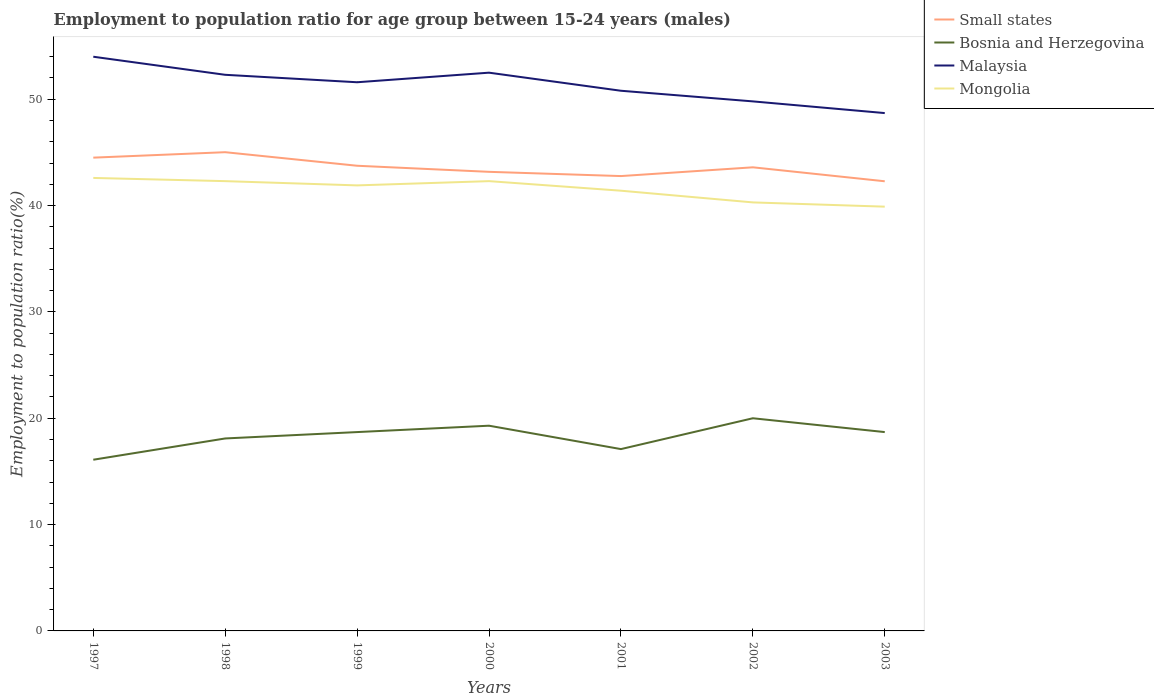Is the number of lines equal to the number of legend labels?
Provide a short and direct response. Yes. Across all years, what is the maximum employment to population ratio in Small states?
Your answer should be compact. 42.29. In which year was the employment to population ratio in Small states maximum?
Your answer should be very brief. 2003. What is the total employment to population ratio in Small states in the graph?
Keep it short and to the point. 0.89. What is the difference between the highest and the second highest employment to population ratio in Small states?
Your response must be concise. 2.73. How many lines are there?
Provide a succinct answer. 4. How many years are there in the graph?
Your response must be concise. 7. What is the difference between two consecutive major ticks on the Y-axis?
Ensure brevity in your answer.  10. Are the values on the major ticks of Y-axis written in scientific E-notation?
Provide a succinct answer. No. How many legend labels are there?
Keep it short and to the point. 4. What is the title of the graph?
Give a very brief answer. Employment to population ratio for age group between 15-24 years (males). What is the label or title of the X-axis?
Your answer should be compact. Years. What is the label or title of the Y-axis?
Keep it short and to the point. Employment to population ratio(%). What is the Employment to population ratio(%) of Small states in 1997?
Offer a very short reply. 44.51. What is the Employment to population ratio(%) of Bosnia and Herzegovina in 1997?
Offer a terse response. 16.1. What is the Employment to population ratio(%) of Mongolia in 1997?
Provide a short and direct response. 42.6. What is the Employment to population ratio(%) of Small states in 1998?
Your response must be concise. 45.02. What is the Employment to population ratio(%) in Bosnia and Herzegovina in 1998?
Ensure brevity in your answer.  18.1. What is the Employment to population ratio(%) in Malaysia in 1998?
Keep it short and to the point. 52.3. What is the Employment to population ratio(%) of Mongolia in 1998?
Your answer should be very brief. 42.3. What is the Employment to population ratio(%) in Small states in 1999?
Make the answer very short. 43.75. What is the Employment to population ratio(%) in Bosnia and Herzegovina in 1999?
Ensure brevity in your answer.  18.7. What is the Employment to population ratio(%) in Malaysia in 1999?
Your answer should be compact. 51.6. What is the Employment to population ratio(%) of Mongolia in 1999?
Your answer should be compact. 41.9. What is the Employment to population ratio(%) in Small states in 2000?
Your answer should be very brief. 43.17. What is the Employment to population ratio(%) in Bosnia and Herzegovina in 2000?
Offer a terse response. 19.3. What is the Employment to population ratio(%) in Malaysia in 2000?
Keep it short and to the point. 52.5. What is the Employment to population ratio(%) in Mongolia in 2000?
Keep it short and to the point. 42.3. What is the Employment to population ratio(%) of Small states in 2001?
Provide a succinct answer. 42.78. What is the Employment to population ratio(%) of Bosnia and Herzegovina in 2001?
Your response must be concise. 17.1. What is the Employment to population ratio(%) in Malaysia in 2001?
Provide a short and direct response. 50.8. What is the Employment to population ratio(%) in Mongolia in 2001?
Give a very brief answer. 41.4. What is the Employment to population ratio(%) of Small states in 2002?
Offer a terse response. 43.6. What is the Employment to population ratio(%) in Bosnia and Herzegovina in 2002?
Provide a succinct answer. 20. What is the Employment to population ratio(%) in Malaysia in 2002?
Offer a terse response. 49.8. What is the Employment to population ratio(%) in Mongolia in 2002?
Give a very brief answer. 40.3. What is the Employment to population ratio(%) in Small states in 2003?
Offer a terse response. 42.29. What is the Employment to population ratio(%) of Bosnia and Herzegovina in 2003?
Provide a short and direct response. 18.7. What is the Employment to population ratio(%) of Malaysia in 2003?
Offer a terse response. 48.7. What is the Employment to population ratio(%) in Mongolia in 2003?
Provide a succinct answer. 39.9. Across all years, what is the maximum Employment to population ratio(%) of Small states?
Offer a terse response. 45.02. Across all years, what is the maximum Employment to population ratio(%) in Bosnia and Herzegovina?
Offer a terse response. 20. Across all years, what is the maximum Employment to population ratio(%) in Mongolia?
Provide a short and direct response. 42.6. Across all years, what is the minimum Employment to population ratio(%) in Small states?
Your answer should be compact. 42.29. Across all years, what is the minimum Employment to population ratio(%) in Bosnia and Herzegovina?
Provide a succinct answer. 16.1. Across all years, what is the minimum Employment to population ratio(%) of Malaysia?
Provide a succinct answer. 48.7. Across all years, what is the minimum Employment to population ratio(%) in Mongolia?
Your response must be concise. 39.9. What is the total Employment to population ratio(%) in Small states in the graph?
Provide a short and direct response. 305.12. What is the total Employment to population ratio(%) in Bosnia and Herzegovina in the graph?
Your answer should be very brief. 128. What is the total Employment to population ratio(%) of Malaysia in the graph?
Provide a succinct answer. 359.7. What is the total Employment to population ratio(%) in Mongolia in the graph?
Offer a very short reply. 290.7. What is the difference between the Employment to population ratio(%) of Small states in 1997 and that in 1998?
Offer a very short reply. -0.51. What is the difference between the Employment to population ratio(%) in Malaysia in 1997 and that in 1998?
Offer a very short reply. 1.7. What is the difference between the Employment to population ratio(%) in Mongolia in 1997 and that in 1998?
Offer a terse response. 0.3. What is the difference between the Employment to population ratio(%) of Small states in 1997 and that in 1999?
Keep it short and to the point. 0.76. What is the difference between the Employment to population ratio(%) in Malaysia in 1997 and that in 1999?
Offer a terse response. 2.4. What is the difference between the Employment to population ratio(%) of Mongolia in 1997 and that in 1999?
Give a very brief answer. 0.7. What is the difference between the Employment to population ratio(%) in Small states in 1997 and that in 2000?
Offer a very short reply. 1.33. What is the difference between the Employment to population ratio(%) of Mongolia in 1997 and that in 2000?
Keep it short and to the point. 0.3. What is the difference between the Employment to population ratio(%) in Small states in 1997 and that in 2001?
Give a very brief answer. 1.73. What is the difference between the Employment to population ratio(%) in Malaysia in 1997 and that in 2001?
Provide a succinct answer. 3.2. What is the difference between the Employment to population ratio(%) in Small states in 1997 and that in 2002?
Your answer should be compact. 0.91. What is the difference between the Employment to population ratio(%) of Bosnia and Herzegovina in 1997 and that in 2002?
Provide a succinct answer. -3.9. What is the difference between the Employment to population ratio(%) of Malaysia in 1997 and that in 2002?
Provide a succinct answer. 4.2. What is the difference between the Employment to population ratio(%) of Small states in 1997 and that in 2003?
Offer a very short reply. 2.22. What is the difference between the Employment to population ratio(%) of Malaysia in 1997 and that in 2003?
Ensure brevity in your answer.  5.3. What is the difference between the Employment to population ratio(%) of Mongolia in 1997 and that in 2003?
Provide a short and direct response. 2.7. What is the difference between the Employment to population ratio(%) of Small states in 1998 and that in 1999?
Your answer should be very brief. 1.27. What is the difference between the Employment to population ratio(%) in Bosnia and Herzegovina in 1998 and that in 1999?
Make the answer very short. -0.6. What is the difference between the Employment to population ratio(%) in Mongolia in 1998 and that in 1999?
Your response must be concise. 0.4. What is the difference between the Employment to population ratio(%) of Small states in 1998 and that in 2000?
Give a very brief answer. 1.85. What is the difference between the Employment to population ratio(%) in Bosnia and Herzegovina in 1998 and that in 2000?
Offer a very short reply. -1.2. What is the difference between the Employment to population ratio(%) of Small states in 1998 and that in 2001?
Provide a succinct answer. 2.25. What is the difference between the Employment to population ratio(%) in Bosnia and Herzegovina in 1998 and that in 2001?
Your response must be concise. 1. What is the difference between the Employment to population ratio(%) in Mongolia in 1998 and that in 2001?
Offer a terse response. 0.9. What is the difference between the Employment to population ratio(%) in Small states in 1998 and that in 2002?
Give a very brief answer. 1.42. What is the difference between the Employment to population ratio(%) in Bosnia and Herzegovina in 1998 and that in 2002?
Offer a terse response. -1.9. What is the difference between the Employment to population ratio(%) in Small states in 1998 and that in 2003?
Your answer should be very brief. 2.73. What is the difference between the Employment to population ratio(%) of Bosnia and Herzegovina in 1998 and that in 2003?
Offer a very short reply. -0.6. What is the difference between the Employment to population ratio(%) of Small states in 1999 and that in 2000?
Provide a short and direct response. 0.57. What is the difference between the Employment to population ratio(%) in Bosnia and Herzegovina in 1999 and that in 2000?
Provide a short and direct response. -0.6. What is the difference between the Employment to population ratio(%) of Malaysia in 1999 and that in 2000?
Your answer should be very brief. -0.9. What is the difference between the Employment to population ratio(%) of Small states in 1999 and that in 2001?
Your answer should be compact. 0.97. What is the difference between the Employment to population ratio(%) of Malaysia in 1999 and that in 2001?
Give a very brief answer. 0.8. What is the difference between the Employment to population ratio(%) in Mongolia in 1999 and that in 2001?
Offer a terse response. 0.5. What is the difference between the Employment to population ratio(%) in Small states in 1999 and that in 2002?
Offer a terse response. 0.15. What is the difference between the Employment to population ratio(%) in Bosnia and Herzegovina in 1999 and that in 2002?
Make the answer very short. -1.3. What is the difference between the Employment to population ratio(%) in Malaysia in 1999 and that in 2002?
Your answer should be compact. 1.8. What is the difference between the Employment to population ratio(%) in Mongolia in 1999 and that in 2002?
Your response must be concise. 1.6. What is the difference between the Employment to population ratio(%) of Small states in 1999 and that in 2003?
Keep it short and to the point. 1.46. What is the difference between the Employment to population ratio(%) in Bosnia and Herzegovina in 1999 and that in 2003?
Your answer should be very brief. 0. What is the difference between the Employment to population ratio(%) of Mongolia in 1999 and that in 2003?
Ensure brevity in your answer.  2. What is the difference between the Employment to population ratio(%) in Small states in 2000 and that in 2001?
Ensure brevity in your answer.  0.4. What is the difference between the Employment to population ratio(%) of Malaysia in 2000 and that in 2001?
Offer a terse response. 1.7. What is the difference between the Employment to population ratio(%) of Small states in 2000 and that in 2002?
Your answer should be very brief. -0.43. What is the difference between the Employment to population ratio(%) in Small states in 2000 and that in 2003?
Provide a short and direct response. 0.89. What is the difference between the Employment to population ratio(%) in Malaysia in 2000 and that in 2003?
Provide a short and direct response. 3.8. What is the difference between the Employment to population ratio(%) of Mongolia in 2000 and that in 2003?
Your answer should be compact. 2.4. What is the difference between the Employment to population ratio(%) in Small states in 2001 and that in 2002?
Make the answer very short. -0.82. What is the difference between the Employment to population ratio(%) of Bosnia and Herzegovina in 2001 and that in 2002?
Your answer should be compact. -2.9. What is the difference between the Employment to population ratio(%) in Mongolia in 2001 and that in 2002?
Your answer should be very brief. 1.1. What is the difference between the Employment to population ratio(%) in Small states in 2001 and that in 2003?
Make the answer very short. 0.49. What is the difference between the Employment to population ratio(%) of Bosnia and Herzegovina in 2001 and that in 2003?
Your answer should be compact. -1.6. What is the difference between the Employment to population ratio(%) in Malaysia in 2001 and that in 2003?
Give a very brief answer. 2.1. What is the difference between the Employment to population ratio(%) in Small states in 2002 and that in 2003?
Give a very brief answer. 1.31. What is the difference between the Employment to population ratio(%) in Mongolia in 2002 and that in 2003?
Provide a succinct answer. 0.4. What is the difference between the Employment to population ratio(%) of Small states in 1997 and the Employment to population ratio(%) of Bosnia and Herzegovina in 1998?
Keep it short and to the point. 26.41. What is the difference between the Employment to population ratio(%) of Small states in 1997 and the Employment to population ratio(%) of Malaysia in 1998?
Your answer should be compact. -7.79. What is the difference between the Employment to population ratio(%) in Small states in 1997 and the Employment to population ratio(%) in Mongolia in 1998?
Offer a very short reply. 2.21. What is the difference between the Employment to population ratio(%) in Bosnia and Herzegovina in 1997 and the Employment to population ratio(%) in Malaysia in 1998?
Offer a terse response. -36.2. What is the difference between the Employment to population ratio(%) in Bosnia and Herzegovina in 1997 and the Employment to population ratio(%) in Mongolia in 1998?
Your answer should be compact. -26.2. What is the difference between the Employment to population ratio(%) in Small states in 1997 and the Employment to population ratio(%) in Bosnia and Herzegovina in 1999?
Provide a succinct answer. 25.81. What is the difference between the Employment to population ratio(%) in Small states in 1997 and the Employment to population ratio(%) in Malaysia in 1999?
Provide a short and direct response. -7.09. What is the difference between the Employment to population ratio(%) of Small states in 1997 and the Employment to population ratio(%) of Mongolia in 1999?
Your answer should be compact. 2.61. What is the difference between the Employment to population ratio(%) in Bosnia and Herzegovina in 1997 and the Employment to population ratio(%) in Malaysia in 1999?
Offer a very short reply. -35.5. What is the difference between the Employment to population ratio(%) of Bosnia and Herzegovina in 1997 and the Employment to population ratio(%) of Mongolia in 1999?
Your answer should be compact. -25.8. What is the difference between the Employment to population ratio(%) of Small states in 1997 and the Employment to population ratio(%) of Bosnia and Herzegovina in 2000?
Give a very brief answer. 25.21. What is the difference between the Employment to population ratio(%) of Small states in 1997 and the Employment to population ratio(%) of Malaysia in 2000?
Offer a terse response. -7.99. What is the difference between the Employment to population ratio(%) in Small states in 1997 and the Employment to population ratio(%) in Mongolia in 2000?
Your answer should be compact. 2.21. What is the difference between the Employment to population ratio(%) of Bosnia and Herzegovina in 1997 and the Employment to population ratio(%) of Malaysia in 2000?
Your answer should be very brief. -36.4. What is the difference between the Employment to population ratio(%) of Bosnia and Herzegovina in 1997 and the Employment to population ratio(%) of Mongolia in 2000?
Your answer should be very brief. -26.2. What is the difference between the Employment to population ratio(%) of Malaysia in 1997 and the Employment to population ratio(%) of Mongolia in 2000?
Provide a short and direct response. 11.7. What is the difference between the Employment to population ratio(%) in Small states in 1997 and the Employment to population ratio(%) in Bosnia and Herzegovina in 2001?
Provide a succinct answer. 27.41. What is the difference between the Employment to population ratio(%) in Small states in 1997 and the Employment to population ratio(%) in Malaysia in 2001?
Offer a very short reply. -6.29. What is the difference between the Employment to population ratio(%) of Small states in 1997 and the Employment to population ratio(%) of Mongolia in 2001?
Ensure brevity in your answer.  3.11. What is the difference between the Employment to population ratio(%) in Bosnia and Herzegovina in 1997 and the Employment to population ratio(%) in Malaysia in 2001?
Provide a succinct answer. -34.7. What is the difference between the Employment to population ratio(%) in Bosnia and Herzegovina in 1997 and the Employment to population ratio(%) in Mongolia in 2001?
Provide a succinct answer. -25.3. What is the difference between the Employment to population ratio(%) of Malaysia in 1997 and the Employment to population ratio(%) of Mongolia in 2001?
Offer a very short reply. 12.6. What is the difference between the Employment to population ratio(%) of Small states in 1997 and the Employment to population ratio(%) of Bosnia and Herzegovina in 2002?
Ensure brevity in your answer.  24.51. What is the difference between the Employment to population ratio(%) in Small states in 1997 and the Employment to population ratio(%) in Malaysia in 2002?
Your answer should be compact. -5.29. What is the difference between the Employment to population ratio(%) in Small states in 1997 and the Employment to population ratio(%) in Mongolia in 2002?
Give a very brief answer. 4.21. What is the difference between the Employment to population ratio(%) in Bosnia and Herzegovina in 1997 and the Employment to population ratio(%) in Malaysia in 2002?
Make the answer very short. -33.7. What is the difference between the Employment to population ratio(%) of Bosnia and Herzegovina in 1997 and the Employment to population ratio(%) of Mongolia in 2002?
Offer a very short reply. -24.2. What is the difference between the Employment to population ratio(%) of Malaysia in 1997 and the Employment to population ratio(%) of Mongolia in 2002?
Offer a terse response. 13.7. What is the difference between the Employment to population ratio(%) in Small states in 1997 and the Employment to population ratio(%) in Bosnia and Herzegovina in 2003?
Your response must be concise. 25.81. What is the difference between the Employment to population ratio(%) of Small states in 1997 and the Employment to population ratio(%) of Malaysia in 2003?
Make the answer very short. -4.19. What is the difference between the Employment to population ratio(%) in Small states in 1997 and the Employment to population ratio(%) in Mongolia in 2003?
Provide a short and direct response. 4.61. What is the difference between the Employment to population ratio(%) of Bosnia and Herzegovina in 1997 and the Employment to population ratio(%) of Malaysia in 2003?
Ensure brevity in your answer.  -32.6. What is the difference between the Employment to population ratio(%) of Bosnia and Herzegovina in 1997 and the Employment to population ratio(%) of Mongolia in 2003?
Offer a very short reply. -23.8. What is the difference between the Employment to population ratio(%) in Small states in 1998 and the Employment to population ratio(%) in Bosnia and Herzegovina in 1999?
Provide a short and direct response. 26.32. What is the difference between the Employment to population ratio(%) of Small states in 1998 and the Employment to population ratio(%) of Malaysia in 1999?
Keep it short and to the point. -6.58. What is the difference between the Employment to population ratio(%) of Small states in 1998 and the Employment to population ratio(%) of Mongolia in 1999?
Offer a terse response. 3.12. What is the difference between the Employment to population ratio(%) in Bosnia and Herzegovina in 1998 and the Employment to population ratio(%) in Malaysia in 1999?
Provide a short and direct response. -33.5. What is the difference between the Employment to population ratio(%) of Bosnia and Herzegovina in 1998 and the Employment to population ratio(%) of Mongolia in 1999?
Your response must be concise. -23.8. What is the difference between the Employment to population ratio(%) of Malaysia in 1998 and the Employment to population ratio(%) of Mongolia in 1999?
Give a very brief answer. 10.4. What is the difference between the Employment to population ratio(%) in Small states in 1998 and the Employment to population ratio(%) in Bosnia and Herzegovina in 2000?
Your response must be concise. 25.72. What is the difference between the Employment to population ratio(%) in Small states in 1998 and the Employment to population ratio(%) in Malaysia in 2000?
Offer a very short reply. -7.48. What is the difference between the Employment to population ratio(%) of Small states in 1998 and the Employment to population ratio(%) of Mongolia in 2000?
Give a very brief answer. 2.72. What is the difference between the Employment to population ratio(%) of Bosnia and Herzegovina in 1998 and the Employment to population ratio(%) of Malaysia in 2000?
Offer a terse response. -34.4. What is the difference between the Employment to population ratio(%) of Bosnia and Herzegovina in 1998 and the Employment to population ratio(%) of Mongolia in 2000?
Ensure brevity in your answer.  -24.2. What is the difference between the Employment to population ratio(%) in Malaysia in 1998 and the Employment to population ratio(%) in Mongolia in 2000?
Keep it short and to the point. 10. What is the difference between the Employment to population ratio(%) in Small states in 1998 and the Employment to population ratio(%) in Bosnia and Herzegovina in 2001?
Keep it short and to the point. 27.92. What is the difference between the Employment to population ratio(%) of Small states in 1998 and the Employment to population ratio(%) of Malaysia in 2001?
Provide a succinct answer. -5.78. What is the difference between the Employment to population ratio(%) in Small states in 1998 and the Employment to population ratio(%) in Mongolia in 2001?
Your answer should be very brief. 3.62. What is the difference between the Employment to population ratio(%) in Bosnia and Herzegovina in 1998 and the Employment to population ratio(%) in Malaysia in 2001?
Give a very brief answer. -32.7. What is the difference between the Employment to population ratio(%) of Bosnia and Herzegovina in 1998 and the Employment to population ratio(%) of Mongolia in 2001?
Give a very brief answer. -23.3. What is the difference between the Employment to population ratio(%) in Small states in 1998 and the Employment to population ratio(%) in Bosnia and Herzegovina in 2002?
Your response must be concise. 25.02. What is the difference between the Employment to population ratio(%) of Small states in 1998 and the Employment to population ratio(%) of Malaysia in 2002?
Give a very brief answer. -4.78. What is the difference between the Employment to population ratio(%) of Small states in 1998 and the Employment to population ratio(%) of Mongolia in 2002?
Your answer should be very brief. 4.72. What is the difference between the Employment to population ratio(%) of Bosnia and Herzegovina in 1998 and the Employment to population ratio(%) of Malaysia in 2002?
Make the answer very short. -31.7. What is the difference between the Employment to population ratio(%) in Bosnia and Herzegovina in 1998 and the Employment to population ratio(%) in Mongolia in 2002?
Make the answer very short. -22.2. What is the difference between the Employment to population ratio(%) of Small states in 1998 and the Employment to population ratio(%) of Bosnia and Herzegovina in 2003?
Provide a succinct answer. 26.32. What is the difference between the Employment to population ratio(%) of Small states in 1998 and the Employment to population ratio(%) of Malaysia in 2003?
Your answer should be compact. -3.68. What is the difference between the Employment to population ratio(%) in Small states in 1998 and the Employment to population ratio(%) in Mongolia in 2003?
Your answer should be compact. 5.12. What is the difference between the Employment to population ratio(%) of Bosnia and Herzegovina in 1998 and the Employment to population ratio(%) of Malaysia in 2003?
Provide a short and direct response. -30.6. What is the difference between the Employment to population ratio(%) in Bosnia and Herzegovina in 1998 and the Employment to population ratio(%) in Mongolia in 2003?
Make the answer very short. -21.8. What is the difference between the Employment to population ratio(%) of Small states in 1999 and the Employment to population ratio(%) of Bosnia and Herzegovina in 2000?
Offer a very short reply. 24.45. What is the difference between the Employment to population ratio(%) of Small states in 1999 and the Employment to population ratio(%) of Malaysia in 2000?
Offer a very short reply. -8.75. What is the difference between the Employment to population ratio(%) of Small states in 1999 and the Employment to population ratio(%) of Mongolia in 2000?
Provide a succinct answer. 1.45. What is the difference between the Employment to population ratio(%) in Bosnia and Herzegovina in 1999 and the Employment to population ratio(%) in Malaysia in 2000?
Your answer should be very brief. -33.8. What is the difference between the Employment to population ratio(%) of Bosnia and Herzegovina in 1999 and the Employment to population ratio(%) of Mongolia in 2000?
Keep it short and to the point. -23.6. What is the difference between the Employment to population ratio(%) of Small states in 1999 and the Employment to population ratio(%) of Bosnia and Herzegovina in 2001?
Provide a succinct answer. 26.65. What is the difference between the Employment to population ratio(%) of Small states in 1999 and the Employment to population ratio(%) of Malaysia in 2001?
Offer a very short reply. -7.05. What is the difference between the Employment to population ratio(%) in Small states in 1999 and the Employment to population ratio(%) in Mongolia in 2001?
Offer a very short reply. 2.35. What is the difference between the Employment to population ratio(%) of Bosnia and Herzegovina in 1999 and the Employment to population ratio(%) of Malaysia in 2001?
Your response must be concise. -32.1. What is the difference between the Employment to population ratio(%) in Bosnia and Herzegovina in 1999 and the Employment to population ratio(%) in Mongolia in 2001?
Provide a succinct answer. -22.7. What is the difference between the Employment to population ratio(%) of Small states in 1999 and the Employment to population ratio(%) of Bosnia and Herzegovina in 2002?
Your answer should be very brief. 23.75. What is the difference between the Employment to population ratio(%) of Small states in 1999 and the Employment to population ratio(%) of Malaysia in 2002?
Keep it short and to the point. -6.05. What is the difference between the Employment to population ratio(%) in Small states in 1999 and the Employment to population ratio(%) in Mongolia in 2002?
Give a very brief answer. 3.45. What is the difference between the Employment to population ratio(%) of Bosnia and Herzegovina in 1999 and the Employment to population ratio(%) of Malaysia in 2002?
Make the answer very short. -31.1. What is the difference between the Employment to population ratio(%) of Bosnia and Herzegovina in 1999 and the Employment to population ratio(%) of Mongolia in 2002?
Offer a terse response. -21.6. What is the difference between the Employment to population ratio(%) of Malaysia in 1999 and the Employment to population ratio(%) of Mongolia in 2002?
Keep it short and to the point. 11.3. What is the difference between the Employment to population ratio(%) of Small states in 1999 and the Employment to population ratio(%) of Bosnia and Herzegovina in 2003?
Give a very brief answer. 25.05. What is the difference between the Employment to population ratio(%) of Small states in 1999 and the Employment to population ratio(%) of Malaysia in 2003?
Provide a short and direct response. -4.95. What is the difference between the Employment to population ratio(%) of Small states in 1999 and the Employment to population ratio(%) of Mongolia in 2003?
Provide a succinct answer. 3.85. What is the difference between the Employment to population ratio(%) in Bosnia and Herzegovina in 1999 and the Employment to population ratio(%) in Mongolia in 2003?
Your answer should be compact. -21.2. What is the difference between the Employment to population ratio(%) in Malaysia in 1999 and the Employment to population ratio(%) in Mongolia in 2003?
Offer a very short reply. 11.7. What is the difference between the Employment to population ratio(%) in Small states in 2000 and the Employment to population ratio(%) in Bosnia and Herzegovina in 2001?
Your answer should be very brief. 26.07. What is the difference between the Employment to population ratio(%) in Small states in 2000 and the Employment to population ratio(%) in Malaysia in 2001?
Your answer should be compact. -7.63. What is the difference between the Employment to population ratio(%) in Small states in 2000 and the Employment to population ratio(%) in Mongolia in 2001?
Your response must be concise. 1.77. What is the difference between the Employment to population ratio(%) of Bosnia and Herzegovina in 2000 and the Employment to population ratio(%) of Malaysia in 2001?
Your response must be concise. -31.5. What is the difference between the Employment to population ratio(%) in Bosnia and Herzegovina in 2000 and the Employment to population ratio(%) in Mongolia in 2001?
Your answer should be very brief. -22.1. What is the difference between the Employment to population ratio(%) in Malaysia in 2000 and the Employment to population ratio(%) in Mongolia in 2001?
Give a very brief answer. 11.1. What is the difference between the Employment to population ratio(%) in Small states in 2000 and the Employment to population ratio(%) in Bosnia and Herzegovina in 2002?
Keep it short and to the point. 23.17. What is the difference between the Employment to population ratio(%) of Small states in 2000 and the Employment to population ratio(%) of Malaysia in 2002?
Provide a short and direct response. -6.63. What is the difference between the Employment to population ratio(%) in Small states in 2000 and the Employment to population ratio(%) in Mongolia in 2002?
Make the answer very short. 2.87. What is the difference between the Employment to population ratio(%) in Bosnia and Herzegovina in 2000 and the Employment to population ratio(%) in Malaysia in 2002?
Offer a very short reply. -30.5. What is the difference between the Employment to population ratio(%) in Malaysia in 2000 and the Employment to population ratio(%) in Mongolia in 2002?
Provide a short and direct response. 12.2. What is the difference between the Employment to population ratio(%) in Small states in 2000 and the Employment to population ratio(%) in Bosnia and Herzegovina in 2003?
Provide a succinct answer. 24.47. What is the difference between the Employment to population ratio(%) of Small states in 2000 and the Employment to population ratio(%) of Malaysia in 2003?
Your answer should be very brief. -5.53. What is the difference between the Employment to population ratio(%) in Small states in 2000 and the Employment to population ratio(%) in Mongolia in 2003?
Your answer should be very brief. 3.27. What is the difference between the Employment to population ratio(%) of Bosnia and Herzegovina in 2000 and the Employment to population ratio(%) of Malaysia in 2003?
Give a very brief answer. -29.4. What is the difference between the Employment to population ratio(%) in Bosnia and Herzegovina in 2000 and the Employment to population ratio(%) in Mongolia in 2003?
Offer a terse response. -20.6. What is the difference between the Employment to population ratio(%) of Small states in 2001 and the Employment to population ratio(%) of Bosnia and Herzegovina in 2002?
Your answer should be compact. 22.78. What is the difference between the Employment to population ratio(%) of Small states in 2001 and the Employment to population ratio(%) of Malaysia in 2002?
Your answer should be very brief. -7.02. What is the difference between the Employment to population ratio(%) in Small states in 2001 and the Employment to population ratio(%) in Mongolia in 2002?
Keep it short and to the point. 2.48. What is the difference between the Employment to population ratio(%) in Bosnia and Herzegovina in 2001 and the Employment to population ratio(%) in Malaysia in 2002?
Your answer should be very brief. -32.7. What is the difference between the Employment to population ratio(%) of Bosnia and Herzegovina in 2001 and the Employment to population ratio(%) of Mongolia in 2002?
Provide a short and direct response. -23.2. What is the difference between the Employment to population ratio(%) in Small states in 2001 and the Employment to population ratio(%) in Bosnia and Herzegovina in 2003?
Ensure brevity in your answer.  24.08. What is the difference between the Employment to population ratio(%) of Small states in 2001 and the Employment to population ratio(%) of Malaysia in 2003?
Your answer should be compact. -5.92. What is the difference between the Employment to population ratio(%) in Small states in 2001 and the Employment to population ratio(%) in Mongolia in 2003?
Offer a very short reply. 2.88. What is the difference between the Employment to population ratio(%) in Bosnia and Herzegovina in 2001 and the Employment to population ratio(%) in Malaysia in 2003?
Your response must be concise. -31.6. What is the difference between the Employment to population ratio(%) in Bosnia and Herzegovina in 2001 and the Employment to population ratio(%) in Mongolia in 2003?
Offer a very short reply. -22.8. What is the difference between the Employment to population ratio(%) in Small states in 2002 and the Employment to population ratio(%) in Bosnia and Herzegovina in 2003?
Your answer should be very brief. 24.9. What is the difference between the Employment to population ratio(%) in Small states in 2002 and the Employment to population ratio(%) in Malaysia in 2003?
Make the answer very short. -5.1. What is the difference between the Employment to population ratio(%) of Small states in 2002 and the Employment to population ratio(%) of Mongolia in 2003?
Provide a succinct answer. 3.7. What is the difference between the Employment to population ratio(%) of Bosnia and Herzegovina in 2002 and the Employment to population ratio(%) of Malaysia in 2003?
Give a very brief answer. -28.7. What is the difference between the Employment to population ratio(%) in Bosnia and Herzegovina in 2002 and the Employment to population ratio(%) in Mongolia in 2003?
Provide a succinct answer. -19.9. What is the average Employment to population ratio(%) in Small states per year?
Offer a very short reply. 43.59. What is the average Employment to population ratio(%) in Bosnia and Herzegovina per year?
Offer a very short reply. 18.29. What is the average Employment to population ratio(%) of Malaysia per year?
Provide a short and direct response. 51.39. What is the average Employment to population ratio(%) of Mongolia per year?
Make the answer very short. 41.53. In the year 1997, what is the difference between the Employment to population ratio(%) in Small states and Employment to population ratio(%) in Bosnia and Herzegovina?
Make the answer very short. 28.41. In the year 1997, what is the difference between the Employment to population ratio(%) in Small states and Employment to population ratio(%) in Malaysia?
Offer a terse response. -9.49. In the year 1997, what is the difference between the Employment to population ratio(%) of Small states and Employment to population ratio(%) of Mongolia?
Your response must be concise. 1.91. In the year 1997, what is the difference between the Employment to population ratio(%) in Bosnia and Herzegovina and Employment to population ratio(%) in Malaysia?
Keep it short and to the point. -37.9. In the year 1997, what is the difference between the Employment to population ratio(%) in Bosnia and Herzegovina and Employment to population ratio(%) in Mongolia?
Ensure brevity in your answer.  -26.5. In the year 1998, what is the difference between the Employment to population ratio(%) in Small states and Employment to population ratio(%) in Bosnia and Herzegovina?
Offer a terse response. 26.92. In the year 1998, what is the difference between the Employment to population ratio(%) of Small states and Employment to population ratio(%) of Malaysia?
Make the answer very short. -7.28. In the year 1998, what is the difference between the Employment to population ratio(%) in Small states and Employment to population ratio(%) in Mongolia?
Provide a succinct answer. 2.72. In the year 1998, what is the difference between the Employment to population ratio(%) of Bosnia and Herzegovina and Employment to population ratio(%) of Malaysia?
Make the answer very short. -34.2. In the year 1998, what is the difference between the Employment to population ratio(%) of Bosnia and Herzegovina and Employment to population ratio(%) of Mongolia?
Your answer should be very brief. -24.2. In the year 1998, what is the difference between the Employment to population ratio(%) of Malaysia and Employment to population ratio(%) of Mongolia?
Provide a succinct answer. 10. In the year 1999, what is the difference between the Employment to population ratio(%) in Small states and Employment to population ratio(%) in Bosnia and Herzegovina?
Provide a succinct answer. 25.05. In the year 1999, what is the difference between the Employment to population ratio(%) in Small states and Employment to population ratio(%) in Malaysia?
Offer a very short reply. -7.85. In the year 1999, what is the difference between the Employment to population ratio(%) of Small states and Employment to population ratio(%) of Mongolia?
Ensure brevity in your answer.  1.85. In the year 1999, what is the difference between the Employment to population ratio(%) of Bosnia and Herzegovina and Employment to population ratio(%) of Malaysia?
Give a very brief answer. -32.9. In the year 1999, what is the difference between the Employment to population ratio(%) of Bosnia and Herzegovina and Employment to population ratio(%) of Mongolia?
Provide a succinct answer. -23.2. In the year 2000, what is the difference between the Employment to population ratio(%) in Small states and Employment to population ratio(%) in Bosnia and Herzegovina?
Give a very brief answer. 23.87. In the year 2000, what is the difference between the Employment to population ratio(%) in Small states and Employment to population ratio(%) in Malaysia?
Give a very brief answer. -9.33. In the year 2000, what is the difference between the Employment to population ratio(%) in Small states and Employment to population ratio(%) in Mongolia?
Provide a short and direct response. 0.87. In the year 2000, what is the difference between the Employment to population ratio(%) in Bosnia and Herzegovina and Employment to population ratio(%) in Malaysia?
Offer a terse response. -33.2. In the year 2000, what is the difference between the Employment to population ratio(%) in Malaysia and Employment to population ratio(%) in Mongolia?
Make the answer very short. 10.2. In the year 2001, what is the difference between the Employment to population ratio(%) in Small states and Employment to population ratio(%) in Bosnia and Herzegovina?
Keep it short and to the point. 25.68. In the year 2001, what is the difference between the Employment to population ratio(%) of Small states and Employment to population ratio(%) of Malaysia?
Your answer should be very brief. -8.02. In the year 2001, what is the difference between the Employment to population ratio(%) of Small states and Employment to population ratio(%) of Mongolia?
Provide a succinct answer. 1.38. In the year 2001, what is the difference between the Employment to population ratio(%) of Bosnia and Herzegovina and Employment to population ratio(%) of Malaysia?
Offer a terse response. -33.7. In the year 2001, what is the difference between the Employment to population ratio(%) of Bosnia and Herzegovina and Employment to population ratio(%) of Mongolia?
Your answer should be very brief. -24.3. In the year 2001, what is the difference between the Employment to population ratio(%) in Malaysia and Employment to population ratio(%) in Mongolia?
Give a very brief answer. 9.4. In the year 2002, what is the difference between the Employment to population ratio(%) of Small states and Employment to population ratio(%) of Bosnia and Herzegovina?
Offer a terse response. 23.6. In the year 2002, what is the difference between the Employment to population ratio(%) of Small states and Employment to population ratio(%) of Malaysia?
Offer a very short reply. -6.2. In the year 2002, what is the difference between the Employment to population ratio(%) in Small states and Employment to population ratio(%) in Mongolia?
Your answer should be very brief. 3.3. In the year 2002, what is the difference between the Employment to population ratio(%) in Bosnia and Herzegovina and Employment to population ratio(%) in Malaysia?
Offer a terse response. -29.8. In the year 2002, what is the difference between the Employment to population ratio(%) of Bosnia and Herzegovina and Employment to population ratio(%) of Mongolia?
Offer a terse response. -20.3. In the year 2002, what is the difference between the Employment to population ratio(%) of Malaysia and Employment to population ratio(%) of Mongolia?
Provide a short and direct response. 9.5. In the year 2003, what is the difference between the Employment to population ratio(%) in Small states and Employment to population ratio(%) in Bosnia and Herzegovina?
Your response must be concise. 23.59. In the year 2003, what is the difference between the Employment to population ratio(%) in Small states and Employment to population ratio(%) in Malaysia?
Make the answer very short. -6.41. In the year 2003, what is the difference between the Employment to population ratio(%) in Small states and Employment to population ratio(%) in Mongolia?
Your answer should be compact. 2.39. In the year 2003, what is the difference between the Employment to population ratio(%) of Bosnia and Herzegovina and Employment to population ratio(%) of Malaysia?
Your answer should be compact. -30. In the year 2003, what is the difference between the Employment to population ratio(%) in Bosnia and Herzegovina and Employment to population ratio(%) in Mongolia?
Give a very brief answer. -21.2. What is the ratio of the Employment to population ratio(%) of Bosnia and Herzegovina in 1997 to that in 1998?
Keep it short and to the point. 0.89. What is the ratio of the Employment to population ratio(%) in Malaysia in 1997 to that in 1998?
Offer a terse response. 1.03. What is the ratio of the Employment to population ratio(%) in Mongolia in 1997 to that in 1998?
Make the answer very short. 1.01. What is the ratio of the Employment to population ratio(%) of Small states in 1997 to that in 1999?
Ensure brevity in your answer.  1.02. What is the ratio of the Employment to population ratio(%) in Bosnia and Herzegovina in 1997 to that in 1999?
Keep it short and to the point. 0.86. What is the ratio of the Employment to population ratio(%) of Malaysia in 1997 to that in 1999?
Ensure brevity in your answer.  1.05. What is the ratio of the Employment to population ratio(%) of Mongolia in 1997 to that in 1999?
Your response must be concise. 1.02. What is the ratio of the Employment to population ratio(%) of Small states in 1997 to that in 2000?
Provide a short and direct response. 1.03. What is the ratio of the Employment to population ratio(%) of Bosnia and Herzegovina in 1997 to that in 2000?
Give a very brief answer. 0.83. What is the ratio of the Employment to population ratio(%) in Malaysia in 1997 to that in 2000?
Ensure brevity in your answer.  1.03. What is the ratio of the Employment to population ratio(%) in Mongolia in 1997 to that in 2000?
Provide a succinct answer. 1.01. What is the ratio of the Employment to population ratio(%) in Small states in 1997 to that in 2001?
Offer a very short reply. 1.04. What is the ratio of the Employment to population ratio(%) in Bosnia and Herzegovina in 1997 to that in 2001?
Your response must be concise. 0.94. What is the ratio of the Employment to population ratio(%) of Malaysia in 1997 to that in 2001?
Offer a very short reply. 1.06. What is the ratio of the Employment to population ratio(%) of Mongolia in 1997 to that in 2001?
Ensure brevity in your answer.  1.03. What is the ratio of the Employment to population ratio(%) in Small states in 1997 to that in 2002?
Offer a very short reply. 1.02. What is the ratio of the Employment to population ratio(%) in Bosnia and Herzegovina in 1997 to that in 2002?
Offer a terse response. 0.81. What is the ratio of the Employment to population ratio(%) of Malaysia in 1997 to that in 2002?
Your answer should be compact. 1.08. What is the ratio of the Employment to population ratio(%) in Mongolia in 1997 to that in 2002?
Provide a short and direct response. 1.06. What is the ratio of the Employment to population ratio(%) of Small states in 1997 to that in 2003?
Offer a very short reply. 1.05. What is the ratio of the Employment to population ratio(%) of Bosnia and Herzegovina in 1997 to that in 2003?
Provide a short and direct response. 0.86. What is the ratio of the Employment to population ratio(%) of Malaysia in 1997 to that in 2003?
Your response must be concise. 1.11. What is the ratio of the Employment to population ratio(%) of Mongolia in 1997 to that in 2003?
Your response must be concise. 1.07. What is the ratio of the Employment to population ratio(%) of Small states in 1998 to that in 1999?
Make the answer very short. 1.03. What is the ratio of the Employment to population ratio(%) in Bosnia and Herzegovina in 1998 to that in 1999?
Make the answer very short. 0.97. What is the ratio of the Employment to population ratio(%) of Malaysia in 1998 to that in 1999?
Provide a succinct answer. 1.01. What is the ratio of the Employment to population ratio(%) in Mongolia in 1998 to that in 1999?
Offer a very short reply. 1.01. What is the ratio of the Employment to population ratio(%) of Small states in 1998 to that in 2000?
Provide a succinct answer. 1.04. What is the ratio of the Employment to population ratio(%) of Bosnia and Herzegovina in 1998 to that in 2000?
Your response must be concise. 0.94. What is the ratio of the Employment to population ratio(%) of Malaysia in 1998 to that in 2000?
Offer a very short reply. 1. What is the ratio of the Employment to population ratio(%) in Small states in 1998 to that in 2001?
Offer a very short reply. 1.05. What is the ratio of the Employment to population ratio(%) of Bosnia and Herzegovina in 1998 to that in 2001?
Your answer should be very brief. 1.06. What is the ratio of the Employment to population ratio(%) in Malaysia in 1998 to that in 2001?
Ensure brevity in your answer.  1.03. What is the ratio of the Employment to population ratio(%) in Mongolia in 1998 to that in 2001?
Provide a succinct answer. 1.02. What is the ratio of the Employment to population ratio(%) in Small states in 1998 to that in 2002?
Ensure brevity in your answer.  1.03. What is the ratio of the Employment to population ratio(%) of Bosnia and Herzegovina in 1998 to that in 2002?
Provide a succinct answer. 0.91. What is the ratio of the Employment to population ratio(%) of Malaysia in 1998 to that in 2002?
Provide a short and direct response. 1.05. What is the ratio of the Employment to population ratio(%) of Mongolia in 1998 to that in 2002?
Give a very brief answer. 1.05. What is the ratio of the Employment to population ratio(%) in Small states in 1998 to that in 2003?
Your answer should be very brief. 1.06. What is the ratio of the Employment to population ratio(%) of Bosnia and Herzegovina in 1998 to that in 2003?
Provide a succinct answer. 0.97. What is the ratio of the Employment to population ratio(%) of Malaysia in 1998 to that in 2003?
Provide a short and direct response. 1.07. What is the ratio of the Employment to population ratio(%) in Mongolia in 1998 to that in 2003?
Your answer should be compact. 1.06. What is the ratio of the Employment to population ratio(%) of Small states in 1999 to that in 2000?
Provide a short and direct response. 1.01. What is the ratio of the Employment to population ratio(%) in Bosnia and Herzegovina in 1999 to that in 2000?
Make the answer very short. 0.97. What is the ratio of the Employment to population ratio(%) of Malaysia in 1999 to that in 2000?
Your answer should be very brief. 0.98. What is the ratio of the Employment to population ratio(%) of Mongolia in 1999 to that in 2000?
Ensure brevity in your answer.  0.99. What is the ratio of the Employment to population ratio(%) in Small states in 1999 to that in 2001?
Make the answer very short. 1.02. What is the ratio of the Employment to population ratio(%) in Bosnia and Herzegovina in 1999 to that in 2001?
Your response must be concise. 1.09. What is the ratio of the Employment to population ratio(%) of Malaysia in 1999 to that in 2001?
Your response must be concise. 1.02. What is the ratio of the Employment to population ratio(%) of Mongolia in 1999 to that in 2001?
Your answer should be compact. 1.01. What is the ratio of the Employment to population ratio(%) in Small states in 1999 to that in 2002?
Provide a succinct answer. 1. What is the ratio of the Employment to population ratio(%) in Bosnia and Herzegovina in 1999 to that in 2002?
Your answer should be compact. 0.94. What is the ratio of the Employment to population ratio(%) in Malaysia in 1999 to that in 2002?
Ensure brevity in your answer.  1.04. What is the ratio of the Employment to population ratio(%) in Mongolia in 1999 to that in 2002?
Offer a terse response. 1.04. What is the ratio of the Employment to population ratio(%) in Small states in 1999 to that in 2003?
Offer a very short reply. 1.03. What is the ratio of the Employment to population ratio(%) in Malaysia in 1999 to that in 2003?
Ensure brevity in your answer.  1.06. What is the ratio of the Employment to population ratio(%) in Mongolia in 1999 to that in 2003?
Ensure brevity in your answer.  1.05. What is the ratio of the Employment to population ratio(%) in Small states in 2000 to that in 2001?
Make the answer very short. 1.01. What is the ratio of the Employment to population ratio(%) of Bosnia and Herzegovina in 2000 to that in 2001?
Offer a very short reply. 1.13. What is the ratio of the Employment to population ratio(%) of Malaysia in 2000 to that in 2001?
Your answer should be very brief. 1.03. What is the ratio of the Employment to population ratio(%) of Mongolia in 2000 to that in 2001?
Your response must be concise. 1.02. What is the ratio of the Employment to population ratio(%) in Small states in 2000 to that in 2002?
Your response must be concise. 0.99. What is the ratio of the Employment to population ratio(%) in Bosnia and Herzegovina in 2000 to that in 2002?
Your answer should be compact. 0.96. What is the ratio of the Employment to population ratio(%) in Malaysia in 2000 to that in 2002?
Give a very brief answer. 1.05. What is the ratio of the Employment to population ratio(%) in Mongolia in 2000 to that in 2002?
Keep it short and to the point. 1.05. What is the ratio of the Employment to population ratio(%) in Small states in 2000 to that in 2003?
Your response must be concise. 1.02. What is the ratio of the Employment to population ratio(%) in Bosnia and Herzegovina in 2000 to that in 2003?
Offer a terse response. 1.03. What is the ratio of the Employment to population ratio(%) of Malaysia in 2000 to that in 2003?
Offer a very short reply. 1.08. What is the ratio of the Employment to population ratio(%) in Mongolia in 2000 to that in 2003?
Give a very brief answer. 1.06. What is the ratio of the Employment to population ratio(%) in Small states in 2001 to that in 2002?
Your answer should be compact. 0.98. What is the ratio of the Employment to population ratio(%) of Bosnia and Herzegovina in 2001 to that in 2002?
Ensure brevity in your answer.  0.85. What is the ratio of the Employment to population ratio(%) of Malaysia in 2001 to that in 2002?
Make the answer very short. 1.02. What is the ratio of the Employment to population ratio(%) in Mongolia in 2001 to that in 2002?
Your response must be concise. 1.03. What is the ratio of the Employment to population ratio(%) in Small states in 2001 to that in 2003?
Make the answer very short. 1.01. What is the ratio of the Employment to population ratio(%) in Bosnia and Herzegovina in 2001 to that in 2003?
Ensure brevity in your answer.  0.91. What is the ratio of the Employment to population ratio(%) of Malaysia in 2001 to that in 2003?
Your response must be concise. 1.04. What is the ratio of the Employment to population ratio(%) in Mongolia in 2001 to that in 2003?
Offer a terse response. 1.04. What is the ratio of the Employment to population ratio(%) in Small states in 2002 to that in 2003?
Ensure brevity in your answer.  1.03. What is the ratio of the Employment to population ratio(%) in Bosnia and Herzegovina in 2002 to that in 2003?
Keep it short and to the point. 1.07. What is the ratio of the Employment to population ratio(%) in Malaysia in 2002 to that in 2003?
Offer a terse response. 1.02. What is the ratio of the Employment to population ratio(%) of Mongolia in 2002 to that in 2003?
Make the answer very short. 1.01. What is the difference between the highest and the second highest Employment to population ratio(%) in Small states?
Provide a succinct answer. 0.51. What is the difference between the highest and the second highest Employment to population ratio(%) in Malaysia?
Your answer should be very brief. 1.5. What is the difference between the highest and the second highest Employment to population ratio(%) of Mongolia?
Keep it short and to the point. 0.3. What is the difference between the highest and the lowest Employment to population ratio(%) in Small states?
Provide a succinct answer. 2.73. What is the difference between the highest and the lowest Employment to population ratio(%) in Bosnia and Herzegovina?
Offer a very short reply. 3.9. 